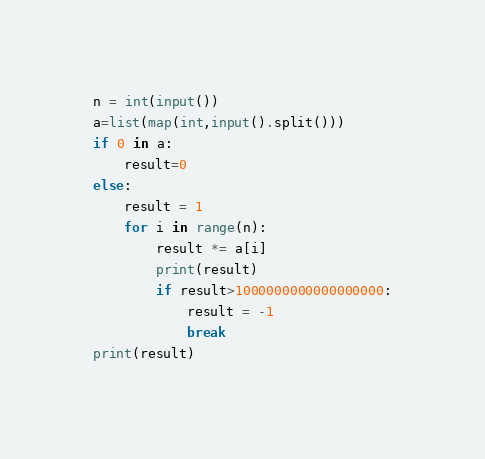Convert code to text. <code><loc_0><loc_0><loc_500><loc_500><_Python_>n = int(input())
a=list(map(int,input().split()))
if 0 in a:
    result=0
else:
    result = 1
    for i in range(n):
        result *= a[i]
        print(result)
        if result>1000000000000000000:
            result = -1
            break
print(result)
</code> 